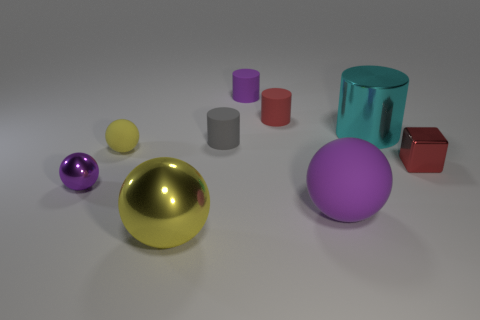How many purple spheres must be subtracted to get 1 purple spheres? 1 Subtract 1 balls. How many balls are left? 3 Add 1 big cyan cylinders. How many objects exist? 10 Subtract all spheres. How many objects are left? 5 Subtract 2 purple balls. How many objects are left? 7 Subtract all purple balls. Subtract all small spheres. How many objects are left? 5 Add 2 small gray things. How many small gray things are left? 3 Add 6 tiny blue metal cylinders. How many tiny blue metal cylinders exist? 6 